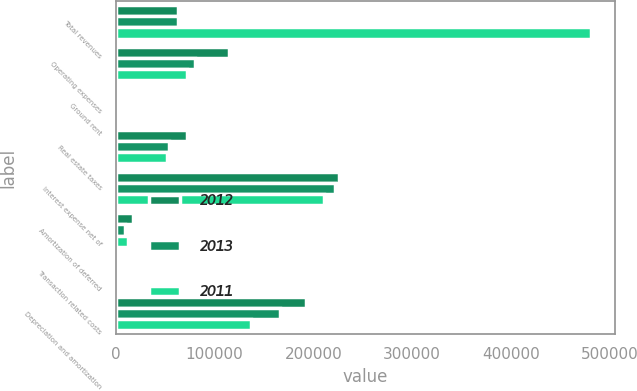Convert chart to OTSL. <chart><loc_0><loc_0><loc_500><loc_500><stacked_bar_chart><ecel><fcel>Total revenues<fcel>Operating expenses<fcel>Ground rent<fcel>Real estate taxes<fcel>Interest expense net of<fcel>Amortization of deferred<fcel>Transaction related costs<fcel>Depreciation and amortization<nl><fcel>2012<fcel>62684<fcel>114633<fcel>2863<fcel>71755<fcel>225765<fcel>17092<fcel>808<fcel>192504<nl><fcel>2013<fcel>62684<fcel>80722<fcel>2975<fcel>53613<fcel>221476<fcel>9739<fcel>2044<fcel>166336<nl><fcel>2011<fcel>480935<fcel>71830<fcel>3683<fcel>51511<fcel>210489<fcel>12911<fcel>2665<fcel>137070<nl></chart> 